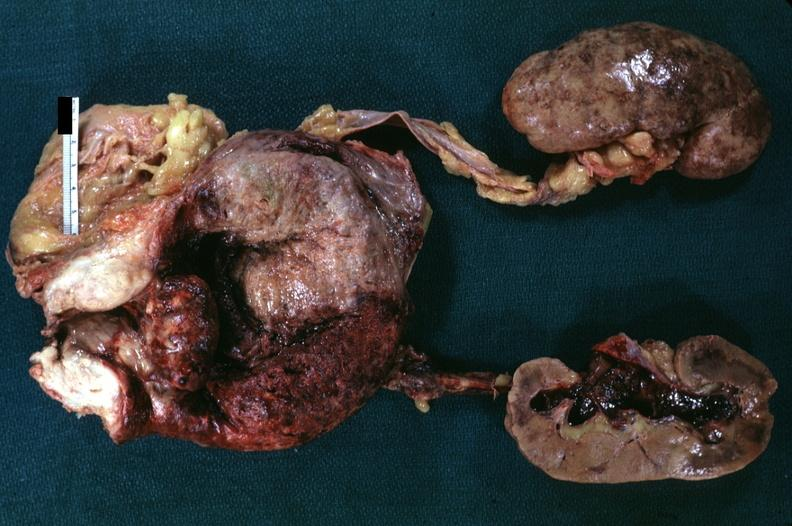s pyelonephritis carcinoma in prostate diagnosis?
Answer the question using a single word or phrase. Yes 